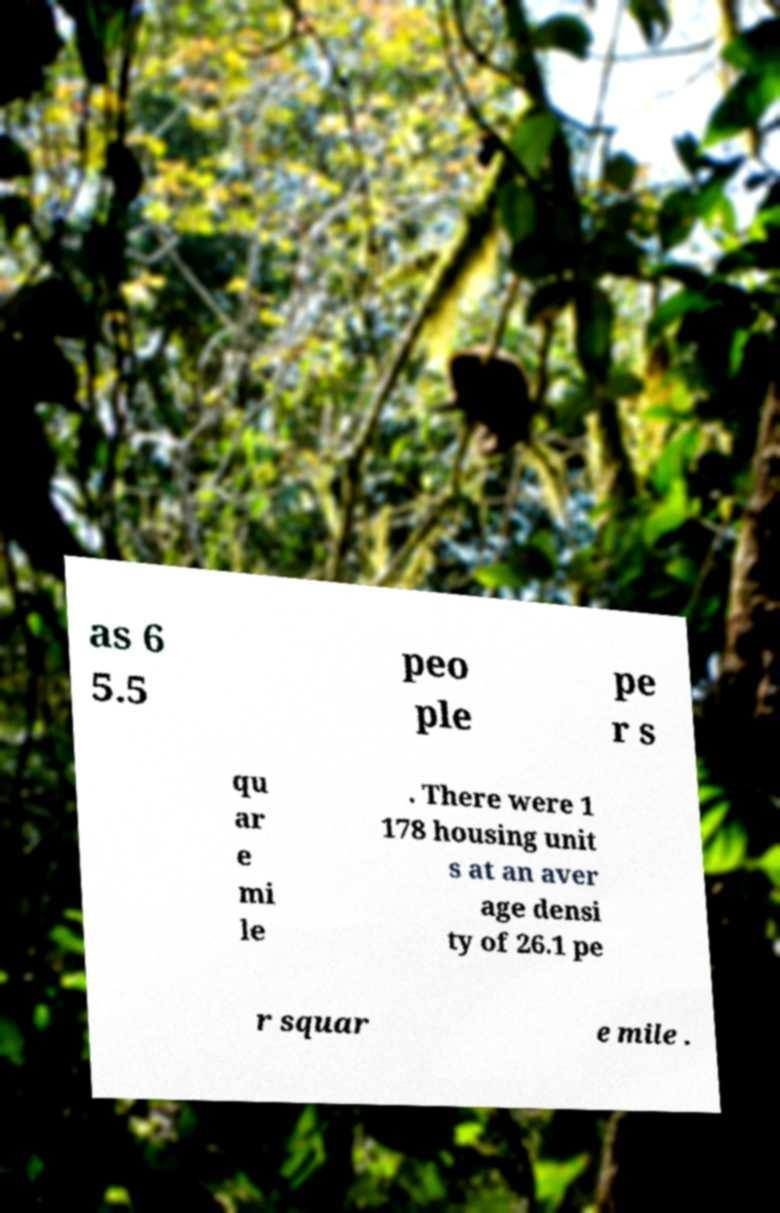Please read and relay the text visible in this image. What does it say? as 6 5.5 peo ple pe r s qu ar e mi le . There were 1 178 housing unit s at an aver age densi ty of 26.1 pe r squar e mile . 